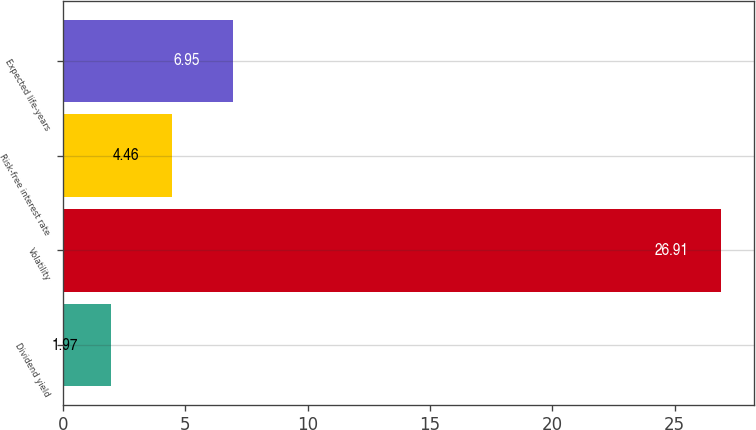Convert chart. <chart><loc_0><loc_0><loc_500><loc_500><bar_chart><fcel>Dividend yield<fcel>Volatility<fcel>Risk-free interest rate<fcel>Expected life-years<nl><fcel>1.97<fcel>26.91<fcel>4.46<fcel>6.95<nl></chart> 